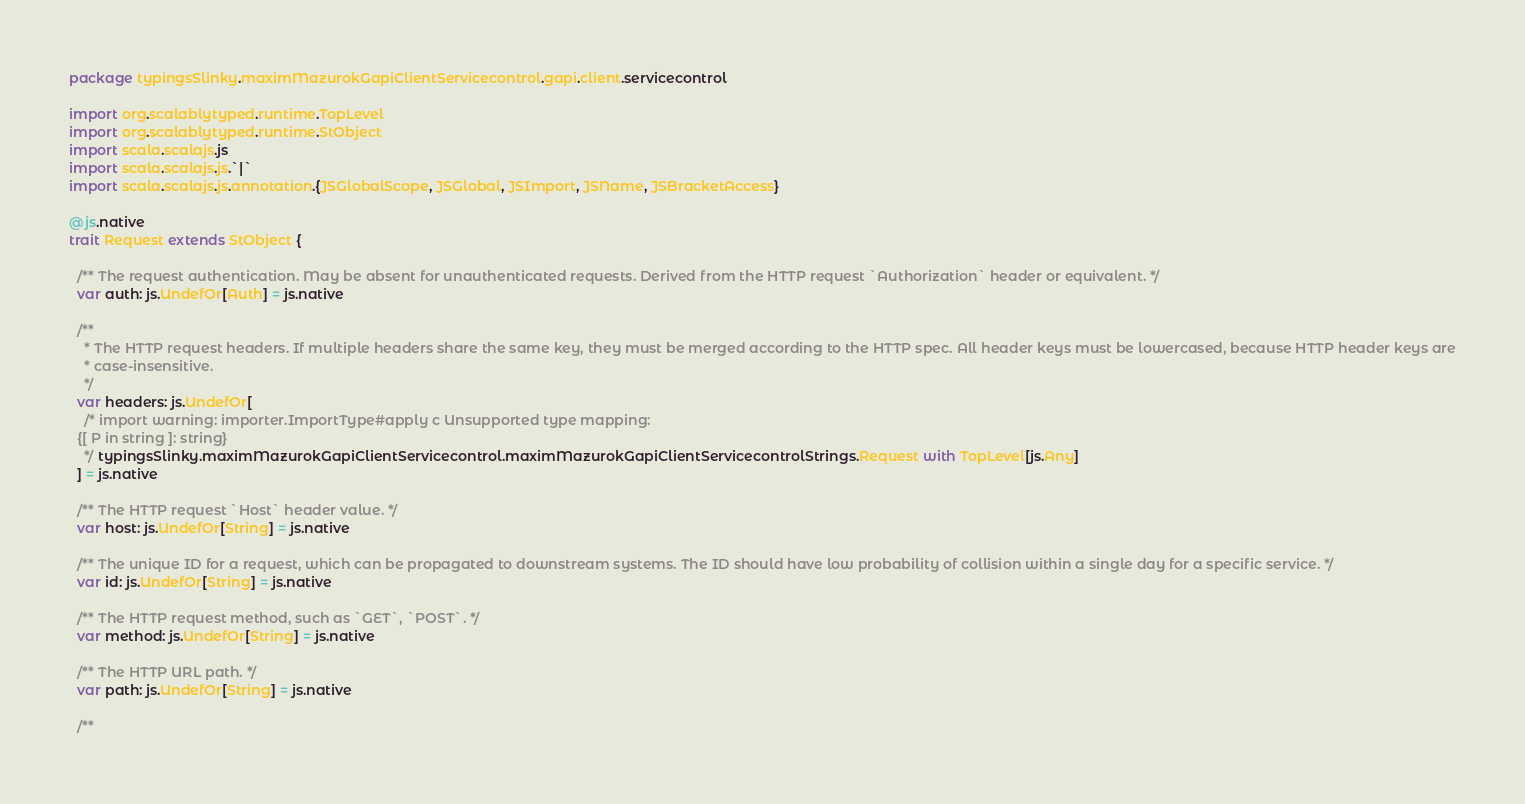Convert code to text. <code><loc_0><loc_0><loc_500><loc_500><_Scala_>package typingsSlinky.maximMazurokGapiClientServicecontrol.gapi.client.servicecontrol

import org.scalablytyped.runtime.TopLevel
import org.scalablytyped.runtime.StObject
import scala.scalajs.js
import scala.scalajs.js.`|`
import scala.scalajs.js.annotation.{JSGlobalScope, JSGlobal, JSImport, JSName, JSBracketAccess}

@js.native
trait Request extends StObject {
  
  /** The request authentication. May be absent for unauthenticated requests. Derived from the HTTP request `Authorization` header or equivalent. */
  var auth: js.UndefOr[Auth] = js.native
  
  /**
    * The HTTP request headers. If multiple headers share the same key, they must be merged according to the HTTP spec. All header keys must be lowercased, because HTTP header keys are
    * case-insensitive.
    */
  var headers: js.UndefOr[
    /* import warning: importer.ImportType#apply c Unsupported type mapping: 
  {[ P in string ]: string}
    */ typingsSlinky.maximMazurokGapiClientServicecontrol.maximMazurokGapiClientServicecontrolStrings.Request with TopLevel[js.Any]
  ] = js.native
  
  /** The HTTP request `Host` header value. */
  var host: js.UndefOr[String] = js.native
  
  /** The unique ID for a request, which can be propagated to downstream systems. The ID should have low probability of collision within a single day for a specific service. */
  var id: js.UndefOr[String] = js.native
  
  /** The HTTP request method, such as `GET`, `POST`. */
  var method: js.UndefOr[String] = js.native
  
  /** The HTTP URL path. */
  var path: js.UndefOr[String] = js.native
  
  /**</code> 